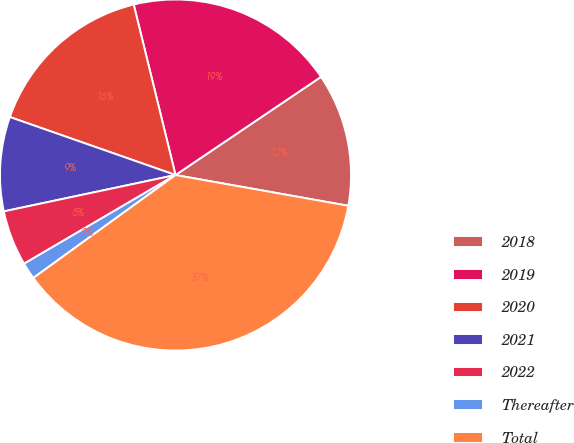Convert chart to OTSL. <chart><loc_0><loc_0><loc_500><loc_500><pie_chart><fcel>2018<fcel>2019<fcel>2020<fcel>2021<fcel>2022<fcel>Thereafter<fcel>Total<nl><fcel>12.25%<fcel>19.38%<fcel>15.81%<fcel>8.68%<fcel>5.11%<fcel>1.54%<fcel>37.22%<nl></chart> 